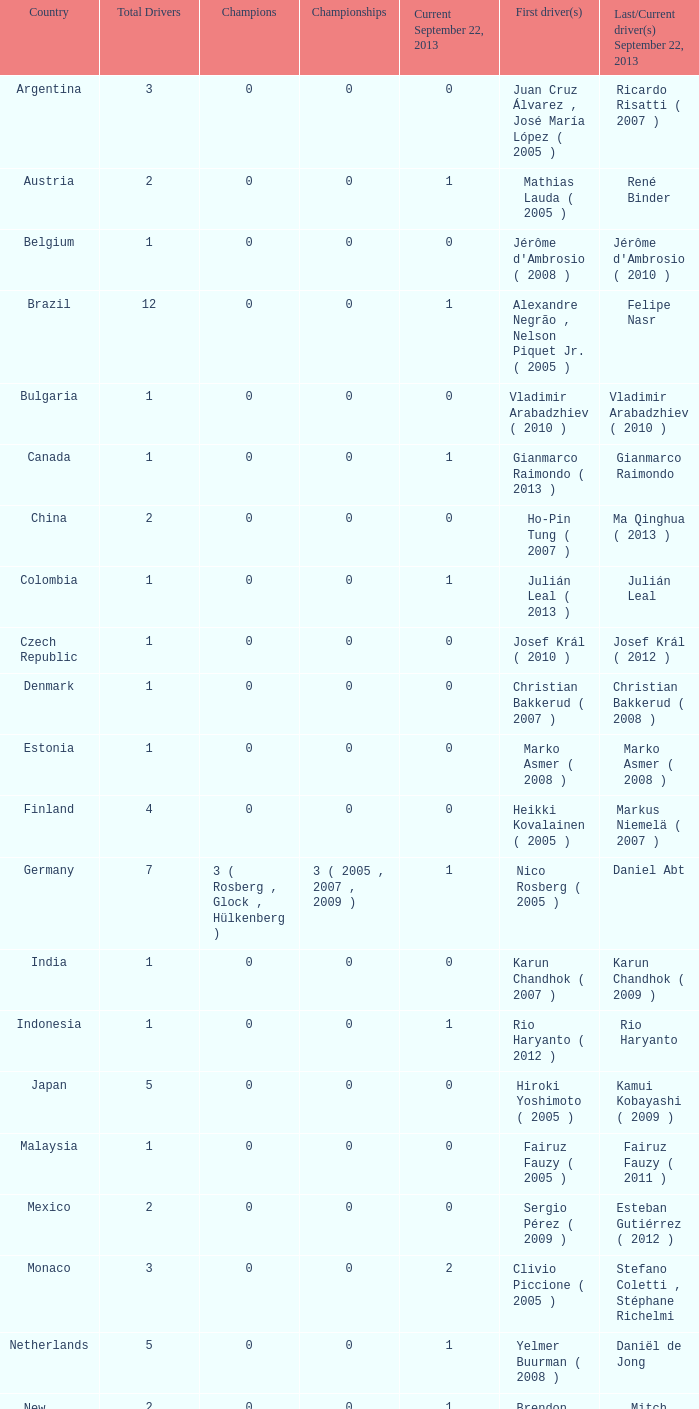How many champions were there when the last driver was Gianmarco Raimondo? 0.0. 